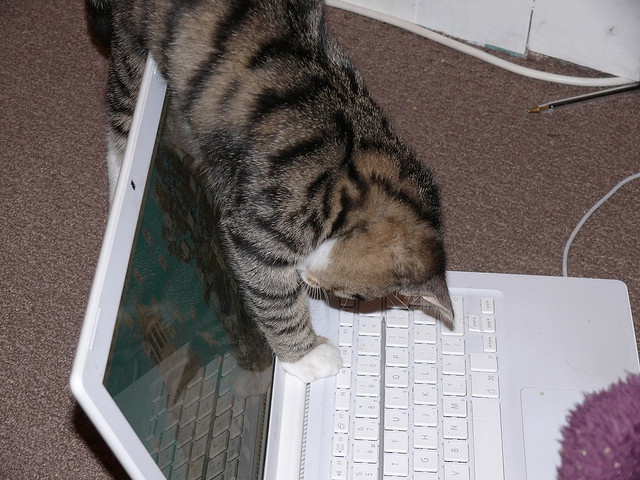Describe the objects in this image and their specific colors. I can see laptop in black, lightgray, gray, and darkgray tones and cat in black and gray tones in this image. 